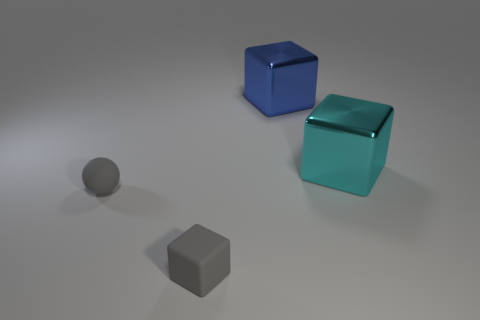Add 3 blocks. How many objects exist? 7 Subtract all cubes. How many objects are left? 1 Subtract 1 gray cubes. How many objects are left? 3 Subtract all tiny gray rubber things. Subtract all big cyan matte cylinders. How many objects are left? 2 Add 1 blue objects. How many blue objects are left? 2 Add 4 small blue metal cylinders. How many small blue metal cylinders exist? 4 